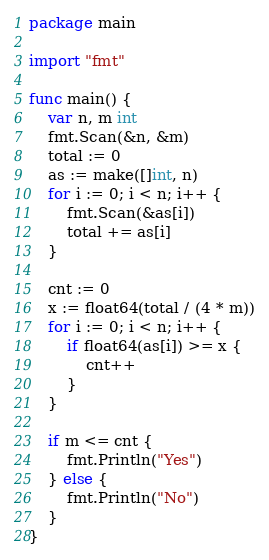<code> <loc_0><loc_0><loc_500><loc_500><_Go_>package main

import "fmt"

func main() {
	var n, m int
	fmt.Scan(&n, &m)
	total := 0
	as := make([]int, n)
	for i := 0; i < n; i++ {
		fmt.Scan(&as[i])
		total += as[i]
	}

	cnt := 0
	x := float64(total / (4 * m))
	for i := 0; i < n; i++ {
		if float64(as[i]) >= x {
			cnt++
		}
	}

	if m <= cnt {
		fmt.Println("Yes")
	} else {
		fmt.Println("No")
	}
}
</code> 